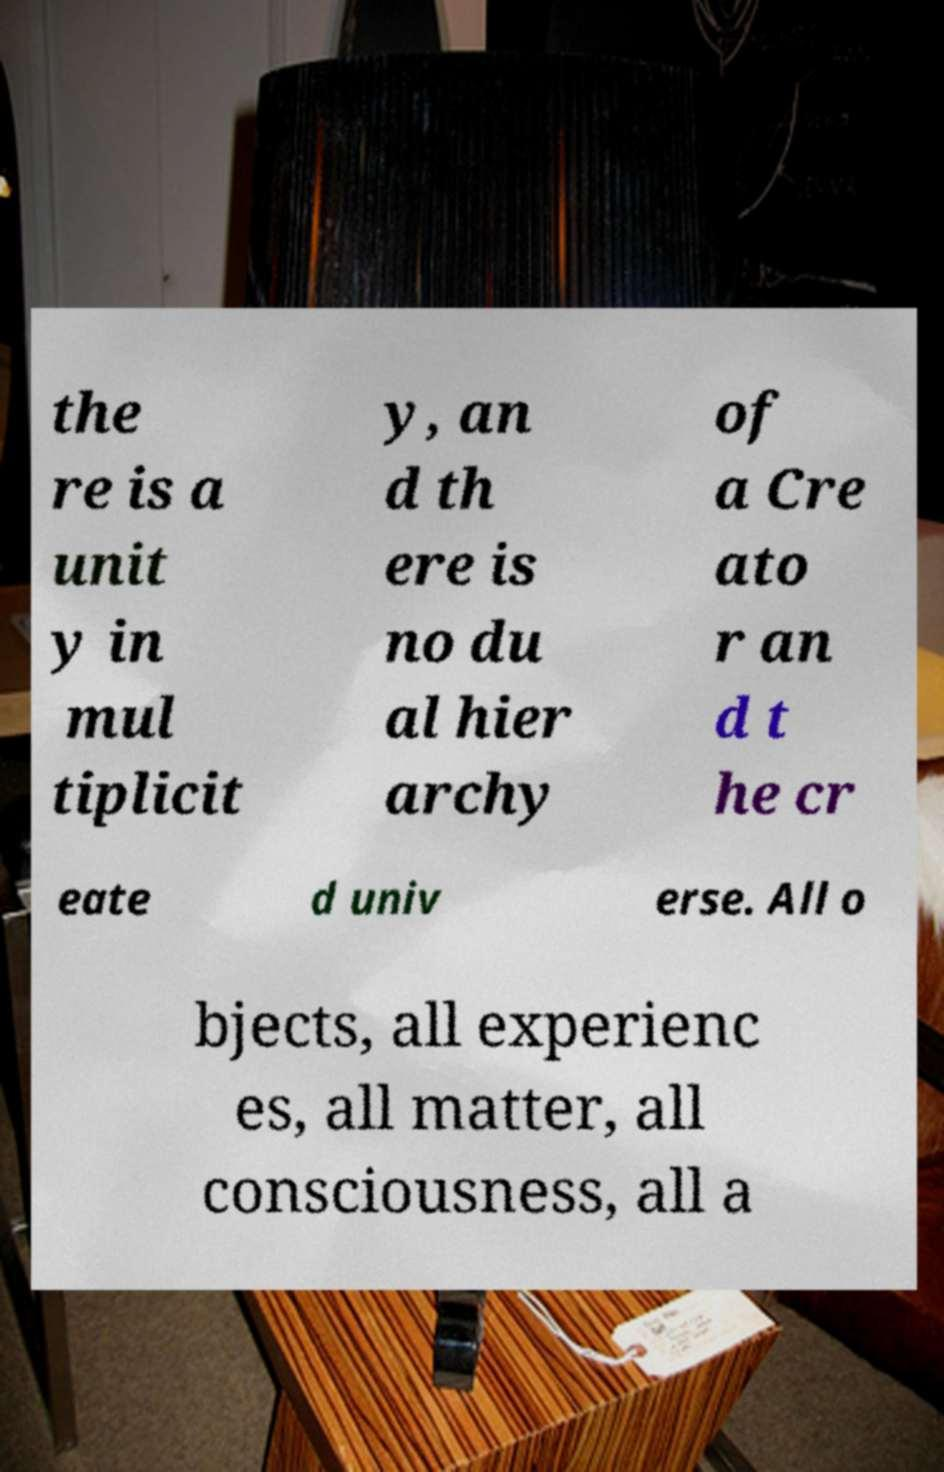Can you read and provide the text displayed in the image?This photo seems to have some interesting text. Can you extract and type it out for me? the re is a unit y in mul tiplicit y, an d th ere is no du al hier archy of a Cre ato r an d t he cr eate d univ erse. All o bjects, all experienc es, all matter, all consciousness, all a 